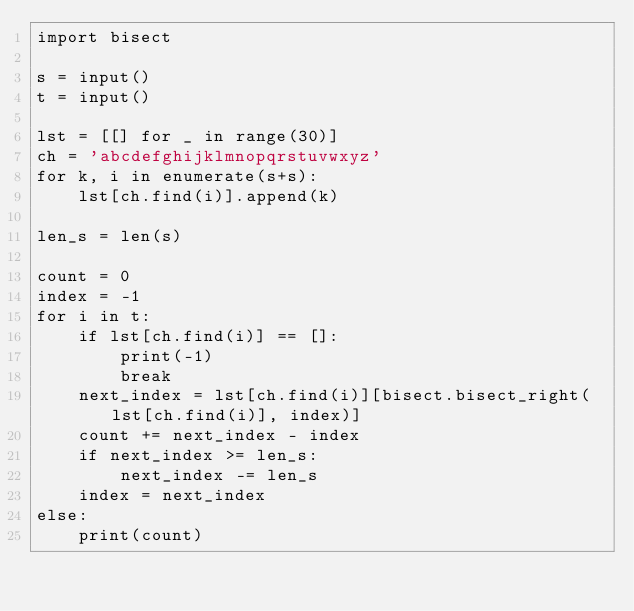<code> <loc_0><loc_0><loc_500><loc_500><_Python_>import bisect

s = input()
t = input()

lst = [[] for _ in range(30)]
ch = 'abcdefghijklmnopqrstuvwxyz'
for k, i in enumerate(s+s):
    lst[ch.find(i)].append(k)

len_s = len(s)

count = 0
index = -1
for i in t:
    if lst[ch.find(i)] == []:
        print(-1)
        break
    next_index = lst[ch.find(i)][bisect.bisect_right(lst[ch.find(i)], index)]
    count += next_index - index
    if next_index >= len_s:
        next_index -= len_s
    index = next_index
else:
    print(count)</code> 